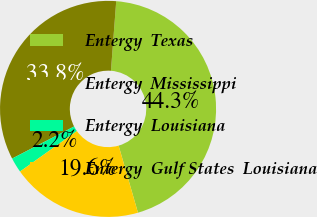Convert chart. <chart><loc_0><loc_0><loc_500><loc_500><pie_chart><fcel>Entergy  Texas<fcel>Entergy  Mississippi<fcel>Entergy  Louisiana<fcel>Entergy  Gulf States  Louisiana<nl><fcel>44.33%<fcel>33.81%<fcel>2.24%<fcel>19.62%<nl></chart> 